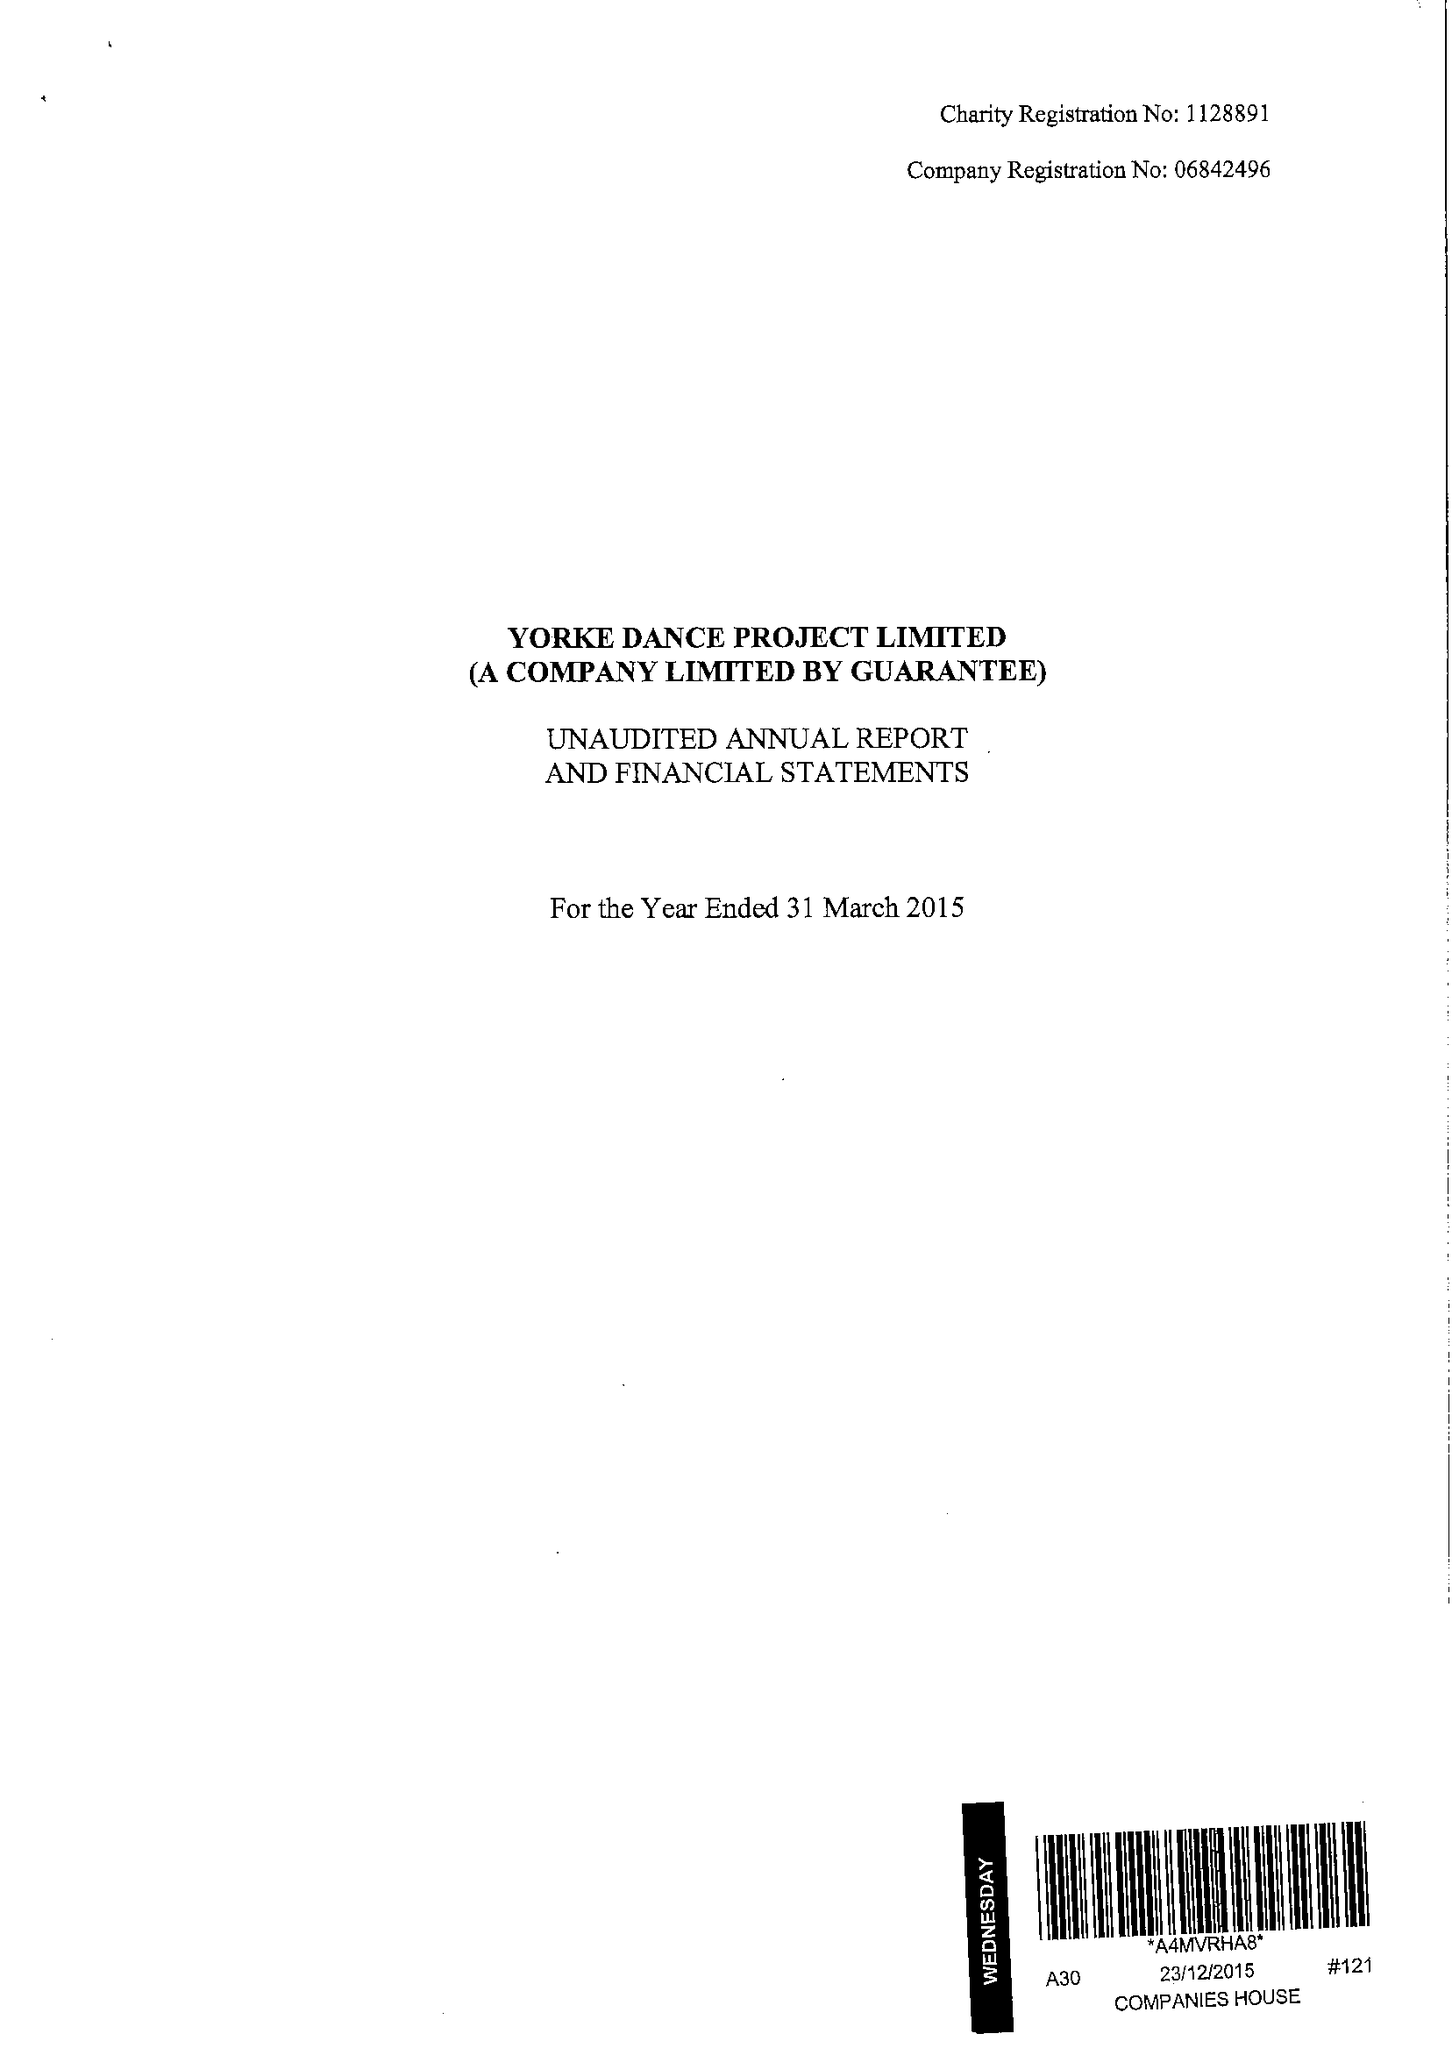What is the value for the report_date?
Answer the question using a single word or phrase. 2015-03-31 